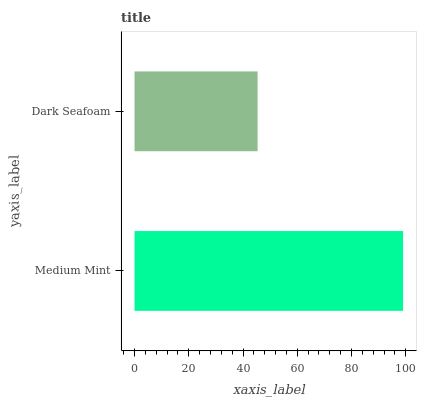Is Dark Seafoam the minimum?
Answer yes or no. Yes. Is Medium Mint the maximum?
Answer yes or no. Yes. Is Dark Seafoam the maximum?
Answer yes or no. No. Is Medium Mint greater than Dark Seafoam?
Answer yes or no. Yes. Is Dark Seafoam less than Medium Mint?
Answer yes or no. Yes. Is Dark Seafoam greater than Medium Mint?
Answer yes or no. No. Is Medium Mint less than Dark Seafoam?
Answer yes or no. No. Is Medium Mint the high median?
Answer yes or no. Yes. Is Dark Seafoam the low median?
Answer yes or no. Yes. Is Dark Seafoam the high median?
Answer yes or no. No. Is Medium Mint the low median?
Answer yes or no. No. 